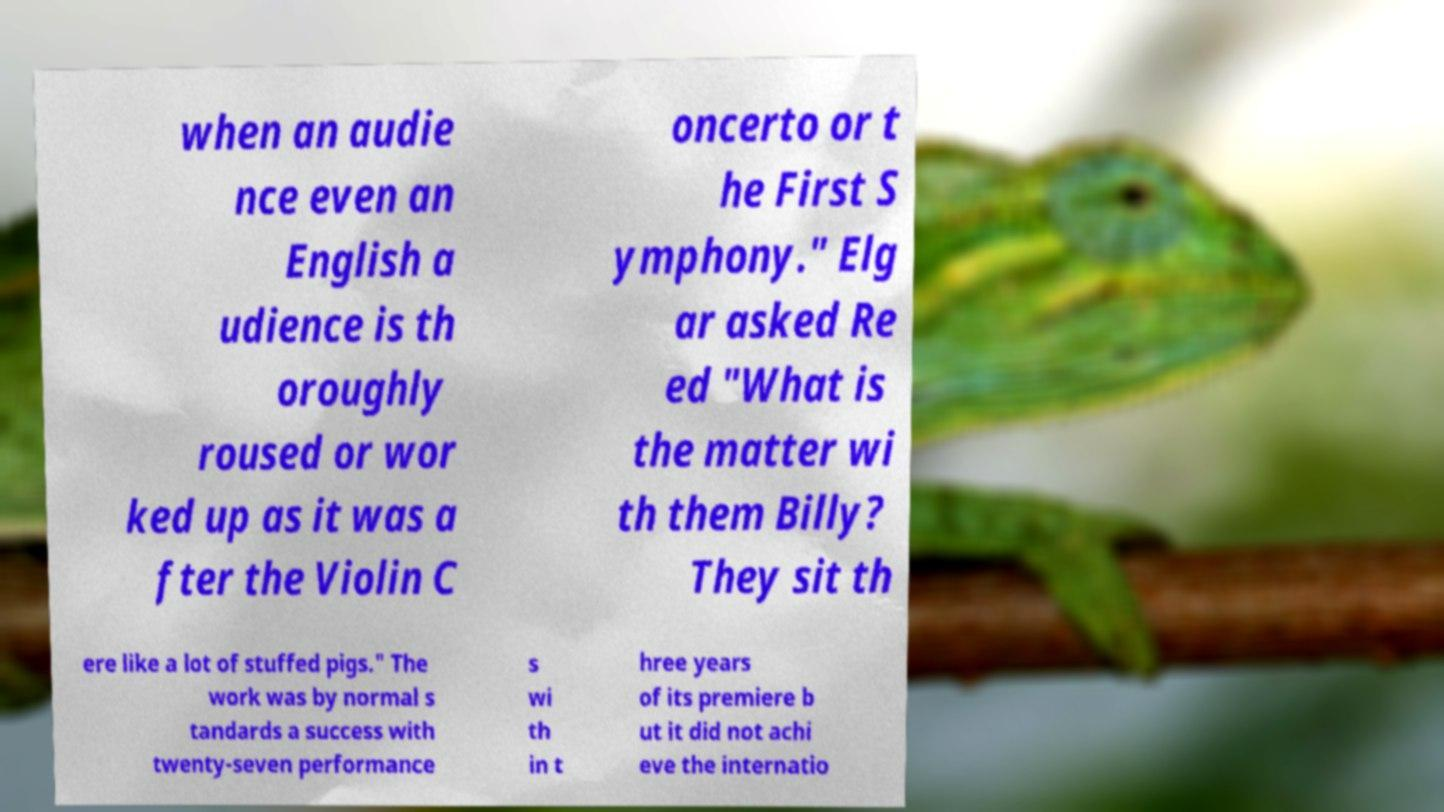Can you read and provide the text displayed in the image?This photo seems to have some interesting text. Can you extract and type it out for me? when an audie nce even an English a udience is th oroughly roused or wor ked up as it was a fter the Violin C oncerto or t he First S ymphony." Elg ar asked Re ed "What is the matter wi th them Billy? They sit th ere like a lot of stuffed pigs." The work was by normal s tandards a success with twenty-seven performance s wi th in t hree years of its premiere b ut it did not achi eve the internatio 